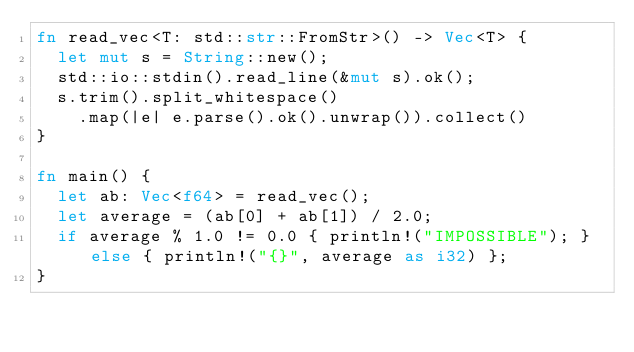Convert code to text. <code><loc_0><loc_0><loc_500><loc_500><_Rust_>fn read_vec<T: std::str::FromStr>() -> Vec<T> {
  let mut s = String::new();
  std::io::stdin().read_line(&mut s).ok();
  s.trim().split_whitespace()
    .map(|e| e.parse().ok().unwrap()).collect()
}

fn main() {
  let ab: Vec<f64> = read_vec();
  let average = (ab[0] + ab[1]) / 2.0;
  if average % 1.0 != 0.0 { println!("IMPOSSIBLE"); } else { println!("{}", average as i32) };
}
</code> 